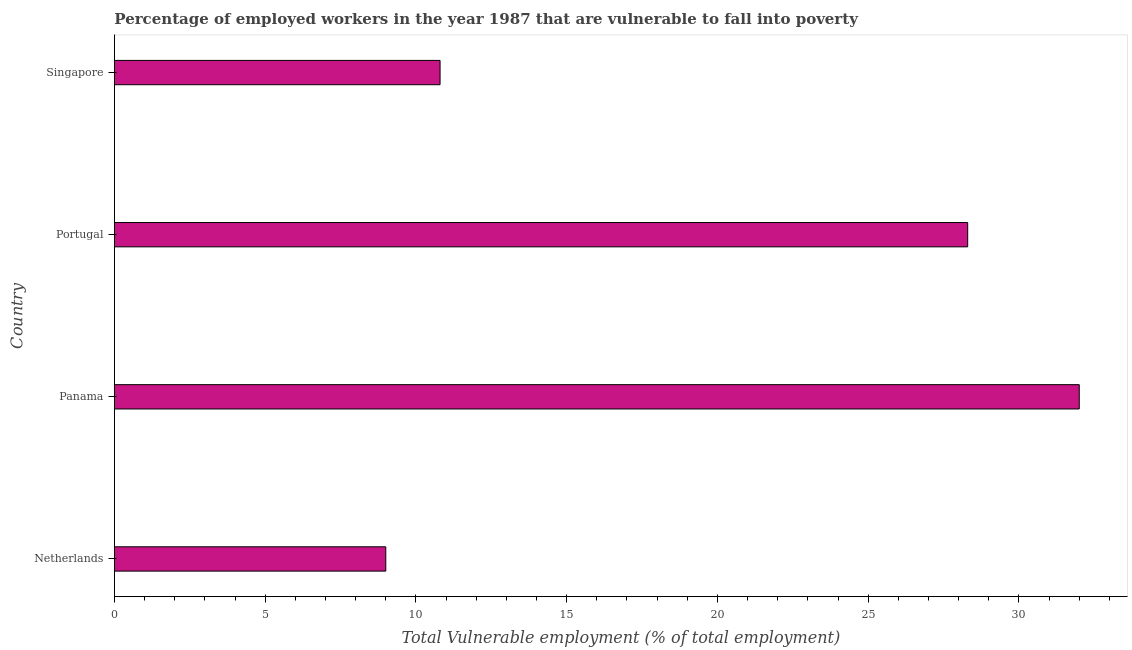Does the graph contain grids?
Offer a terse response. No. What is the title of the graph?
Keep it short and to the point. Percentage of employed workers in the year 1987 that are vulnerable to fall into poverty. What is the label or title of the X-axis?
Offer a terse response. Total Vulnerable employment (% of total employment). What is the total vulnerable employment in Panama?
Offer a very short reply. 32. Across all countries, what is the maximum total vulnerable employment?
Ensure brevity in your answer.  32. Across all countries, what is the minimum total vulnerable employment?
Give a very brief answer. 9. In which country was the total vulnerable employment maximum?
Your response must be concise. Panama. In which country was the total vulnerable employment minimum?
Provide a succinct answer. Netherlands. What is the sum of the total vulnerable employment?
Offer a terse response. 80.1. What is the difference between the total vulnerable employment in Netherlands and Panama?
Keep it short and to the point. -23. What is the average total vulnerable employment per country?
Provide a short and direct response. 20.02. What is the median total vulnerable employment?
Provide a short and direct response. 19.55. In how many countries, is the total vulnerable employment greater than 10 %?
Ensure brevity in your answer.  3. What is the ratio of the total vulnerable employment in Netherlands to that in Portugal?
Your answer should be compact. 0.32. What is the difference between the highest and the lowest total vulnerable employment?
Give a very brief answer. 23. In how many countries, is the total vulnerable employment greater than the average total vulnerable employment taken over all countries?
Make the answer very short. 2. How many bars are there?
Ensure brevity in your answer.  4. How many countries are there in the graph?
Give a very brief answer. 4. Are the values on the major ticks of X-axis written in scientific E-notation?
Make the answer very short. No. What is the Total Vulnerable employment (% of total employment) in Netherlands?
Give a very brief answer. 9. What is the Total Vulnerable employment (% of total employment) of Portugal?
Offer a terse response. 28.3. What is the Total Vulnerable employment (% of total employment) in Singapore?
Provide a succinct answer. 10.8. What is the difference between the Total Vulnerable employment (% of total employment) in Netherlands and Panama?
Make the answer very short. -23. What is the difference between the Total Vulnerable employment (% of total employment) in Netherlands and Portugal?
Ensure brevity in your answer.  -19.3. What is the difference between the Total Vulnerable employment (% of total employment) in Panama and Singapore?
Give a very brief answer. 21.2. What is the ratio of the Total Vulnerable employment (% of total employment) in Netherlands to that in Panama?
Your response must be concise. 0.28. What is the ratio of the Total Vulnerable employment (% of total employment) in Netherlands to that in Portugal?
Ensure brevity in your answer.  0.32. What is the ratio of the Total Vulnerable employment (% of total employment) in Netherlands to that in Singapore?
Your response must be concise. 0.83. What is the ratio of the Total Vulnerable employment (% of total employment) in Panama to that in Portugal?
Offer a terse response. 1.13. What is the ratio of the Total Vulnerable employment (% of total employment) in Panama to that in Singapore?
Your answer should be very brief. 2.96. What is the ratio of the Total Vulnerable employment (% of total employment) in Portugal to that in Singapore?
Provide a succinct answer. 2.62. 